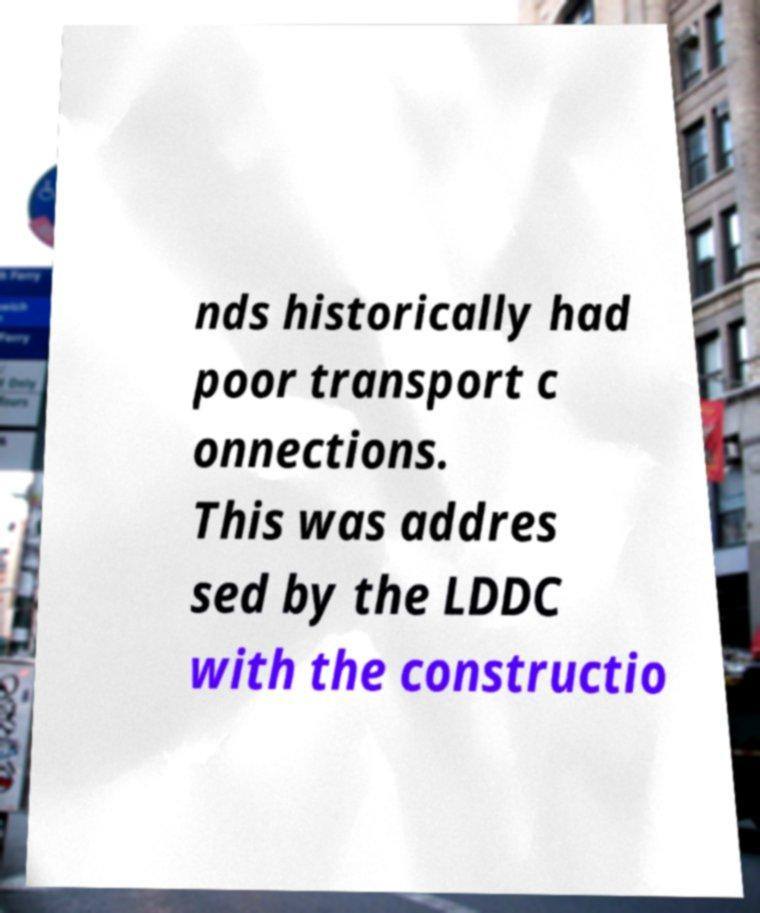There's text embedded in this image that I need extracted. Can you transcribe it verbatim? nds historically had poor transport c onnections. This was addres sed by the LDDC with the constructio 